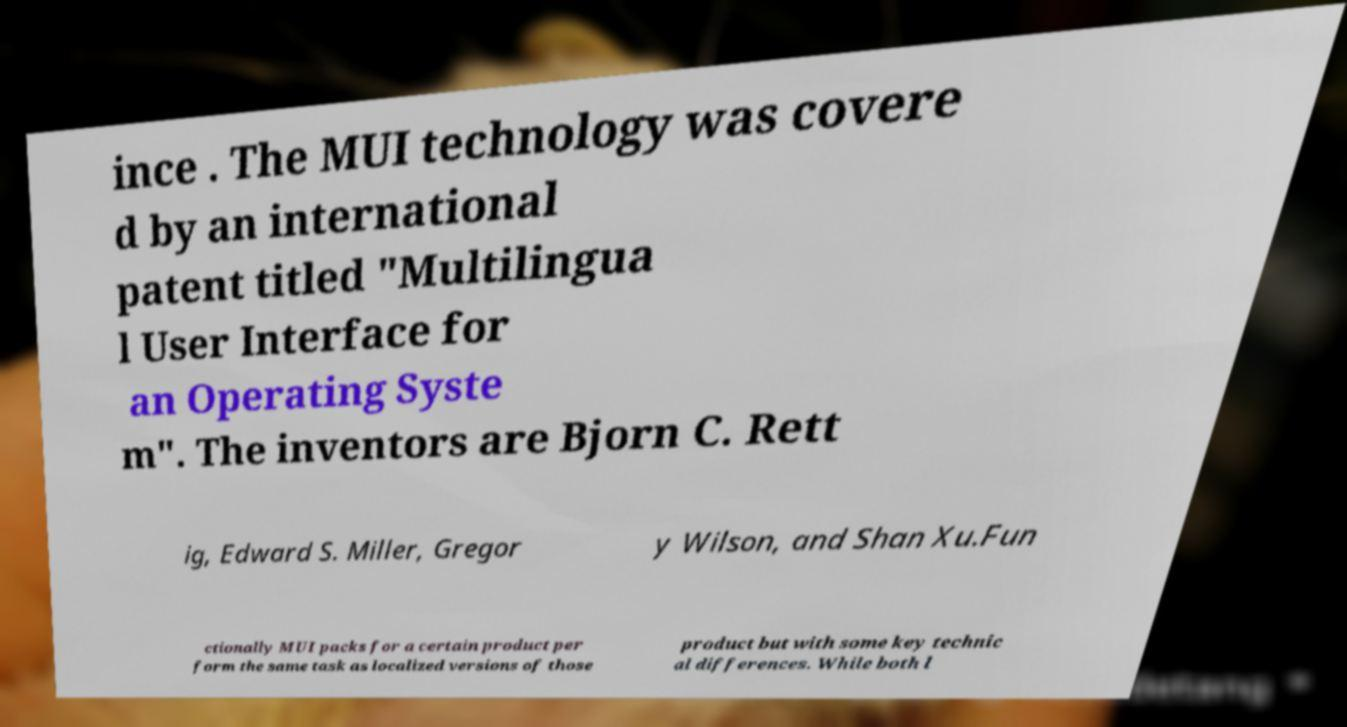Can you read and provide the text displayed in the image?This photo seems to have some interesting text. Can you extract and type it out for me? ince . The MUI technology was covere d by an international patent titled "Multilingua l User Interface for an Operating Syste m". The inventors are Bjorn C. Rett ig, Edward S. Miller, Gregor y Wilson, and Shan Xu.Fun ctionally MUI packs for a certain product per form the same task as localized versions of those product but with some key technic al differences. While both l 